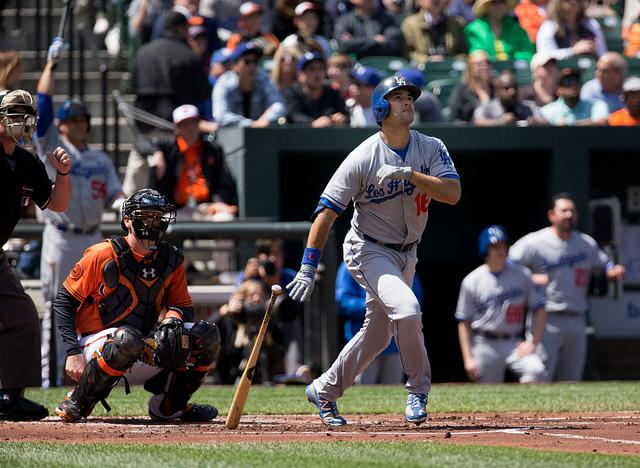The player just hit the ball so he watches it while he runs to what base?

Choices:
A) second
B) home
C) first
D) fourth first 